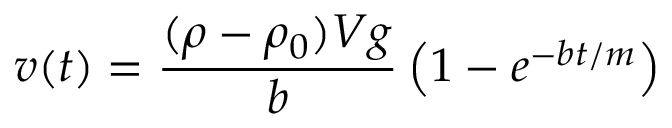Convert formula to latex. <formula><loc_0><loc_0><loc_500><loc_500>v ( t ) = { \frac { ( \rho - \rho _ { 0 } ) V g } { b } } \left ( 1 - e ^ { - b t / m } \right )</formula> 